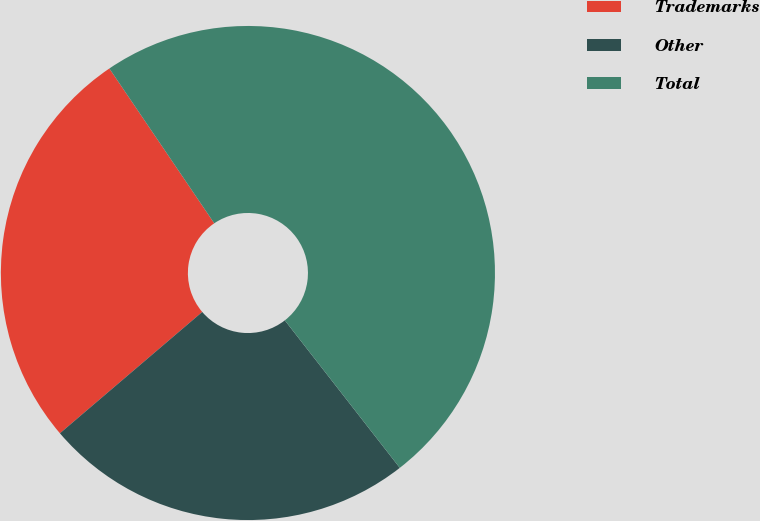Convert chart. <chart><loc_0><loc_0><loc_500><loc_500><pie_chart><fcel>Trademarks<fcel>Other<fcel>Total<nl><fcel>26.76%<fcel>24.3%<fcel>48.94%<nl></chart> 